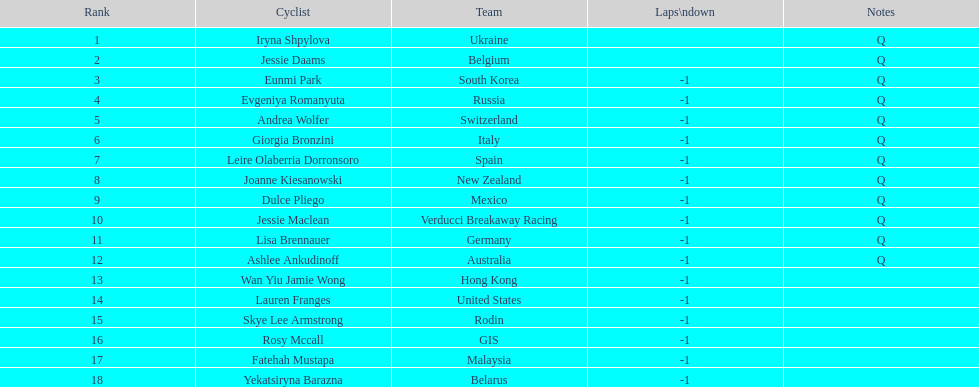What is the number of cyclists without -1 laps down? 2. 